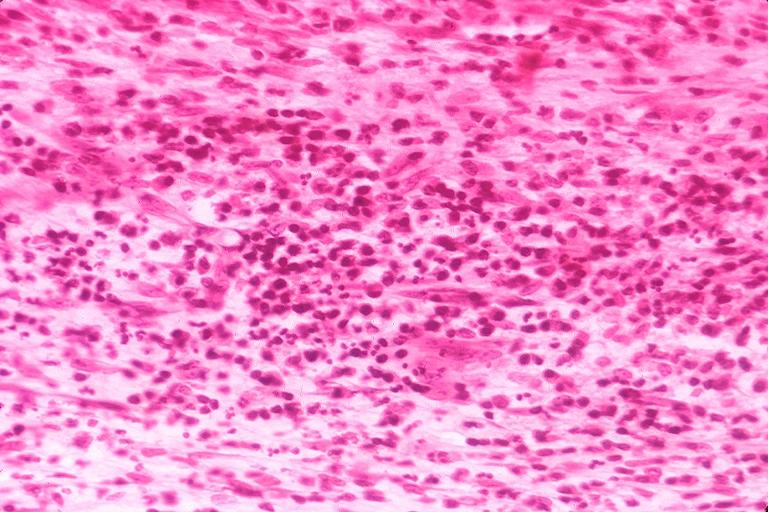does this image show chronic pulpitis?
Answer the question using a single word or phrase. Yes 